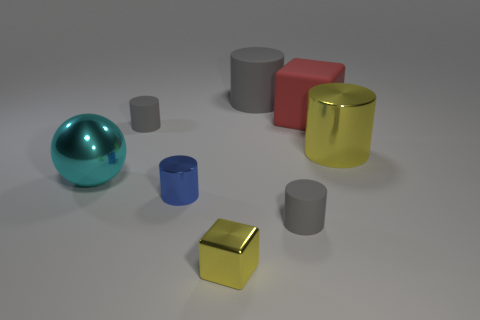Subtract all yellow cylinders. How many cylinders are left? 4 Add 1 large purple matte spheres. How many objects exist? 9 Subtract all blue cylinders. How many cylinders are left? 4 Subtract all blocks. How many objects are left? 6 Subtract 2 cylinders. How many cylinders are left? 3 Add 3 large blocks. How many large blocks exist? 4 Subtract 0 brown cubes. How many objects are left? 8 Subtract all green cylinders. Subtract all yellow blocks. How many cylinders are left? 5 Subtract all red cubes. How many yellow balls are left? 0 Subtract all tiny shiny cubes. Subtract all small gray things. How many objects are left? 5 